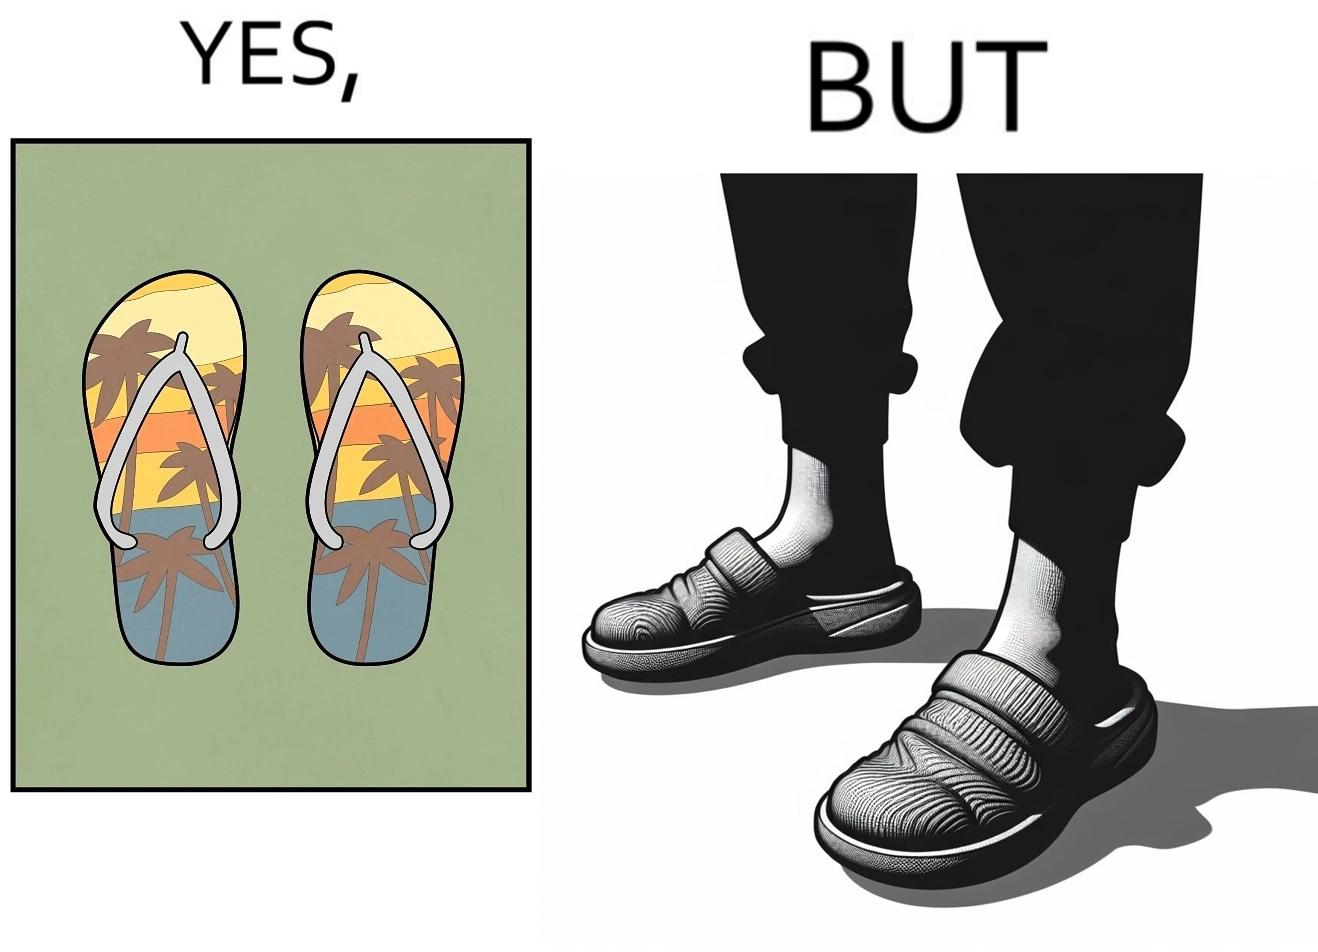What does this image depict? The image is ironical, as when a person wear a pair of slippers with a colorful image, it is almost completely hidden due to the legs of the person wearing the slippers, which counters the point of having such colorful slippers. 